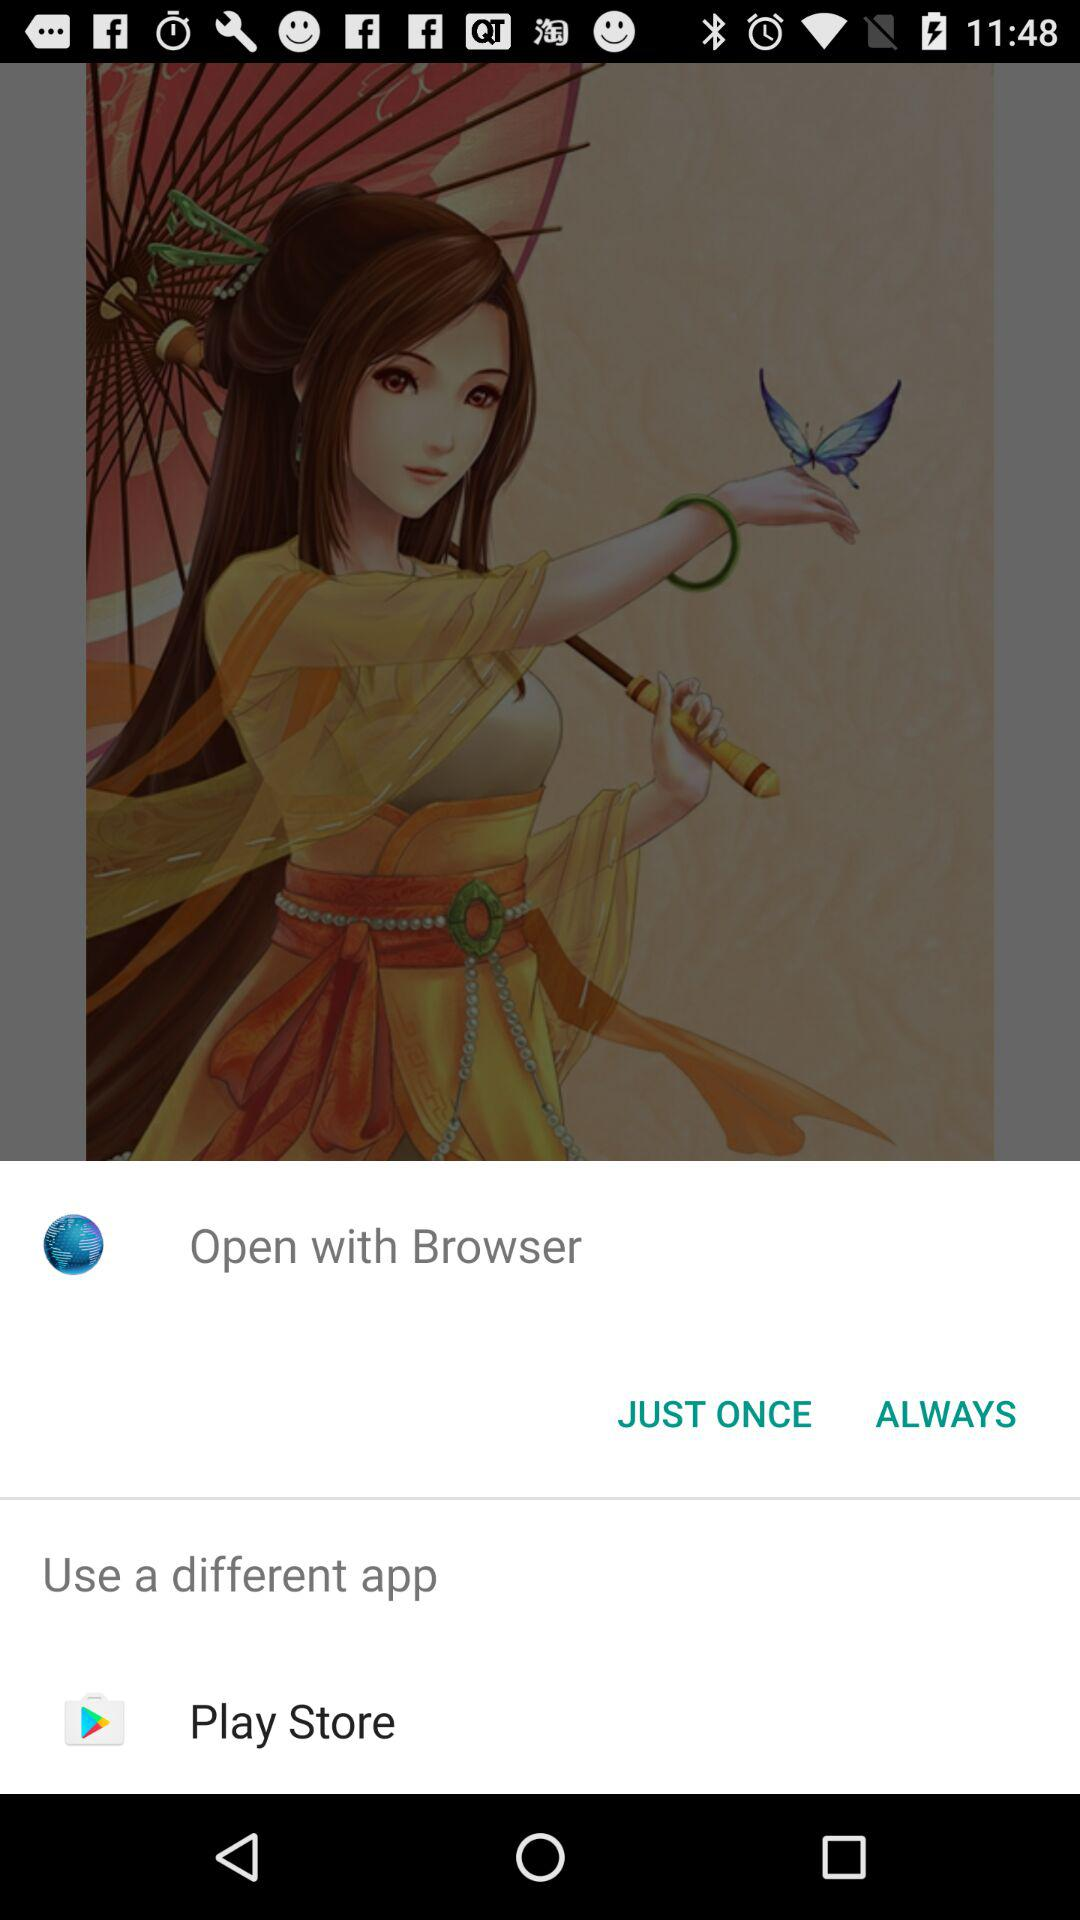What are the different options to open with? The different options to open with are "Browser" and "Play Store". 